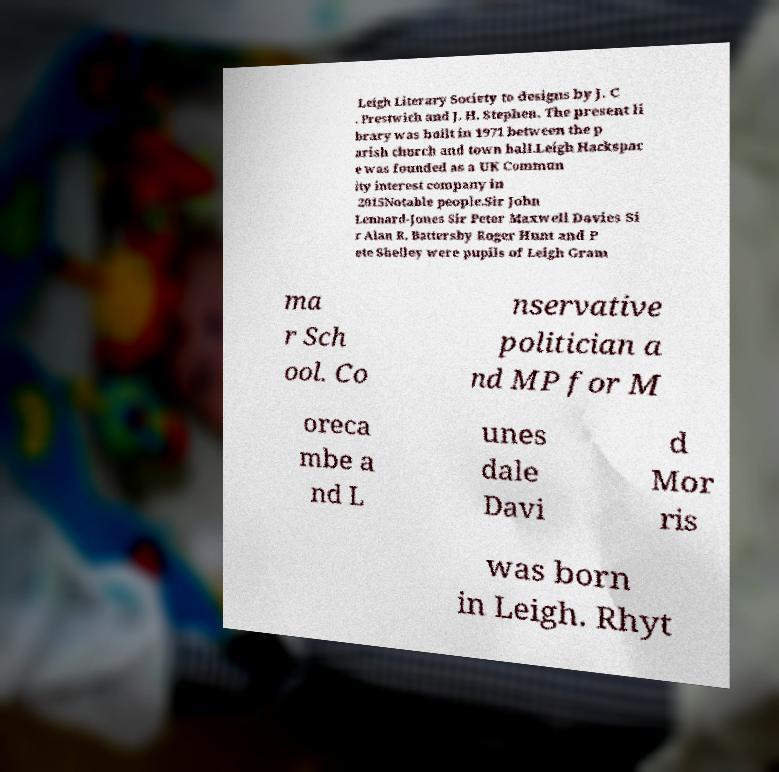There's text embedded in this image that I need extracted. Can you transcribe it verbatim? Leigh Literary Society to designs by J. C . Prestwich and J. H. Stephen. The present li brary was built in 1971 between the p arish church and town hall.Leigh Hackspac e was founded as a UK Commun ity interest company in 2015Notable people.Sir John Lennard-Jones Sir Peter Maxwell Davies Si r Alan R. Battersby Roger Hunt and P ete Shelley were pupils of Leigh Gram ma r Sch ool. Co nservative politician a nd MP for M oreca mbe a nd L unes dale Davi d Mor ris was born in Leigh. Rhyt 